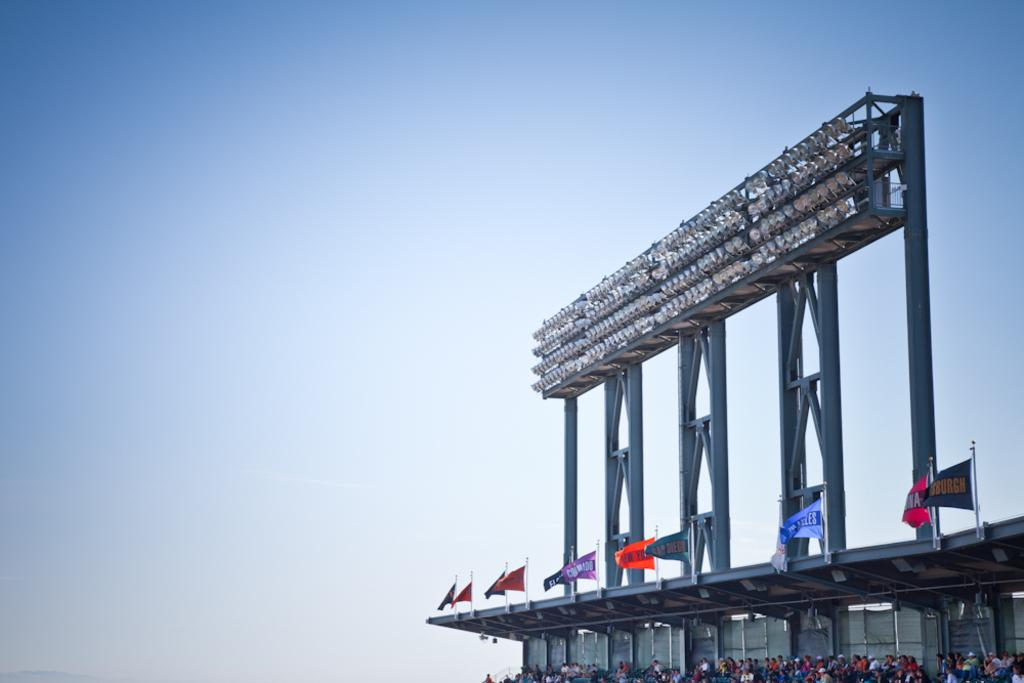What are the people in the image doing? The people are sitting in the image. Where are the people located in the image? The people are located at the right bottom of the image. What else can be seen in the image besides the people? There are flags and lights in the image. What is visible at the top of the image? The sky is visible at the top of the image. What type of knee injury can be seen on the person in the image? There is no knee injury visible in the image; the people are simply sitting. How hot is the temperature in the image? The temperature is not mentioned in the image, and there is no indication of heat or cold. 